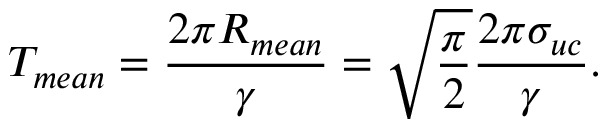<formula> <loc_0><loc_0><loc_500><loc_500>T _ { m e a n } = \frac { 2 \pi R _ { m e a n } } { \gamma } = \sqrt { \frac { \pi } { 2 } } \frac { 2 \pi \sigma _ { u c } } { \gamma } .</formula> 